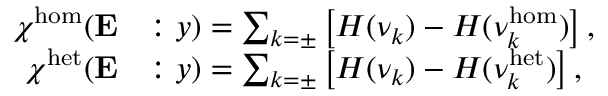Convert formula to latex. <formula><loc_0><loc_0><loc_500><loc_500>\begin{array} { r l } { \chi ^ { h o m } ( E } & { \colon y ) = \sum _ { k = \pm } \left [ H ( \nu _ { k } ) - H ( \nu _ { k } ^ { h o m } ) \right ] , } \\ { \chi ^ { h e t } ( E } & { \colon y ) = \sum _ { k = \pm } \left [ H ( \nu _ { k } ) - H ( \nu _ { k } ^ { h e t } ) \right ] , } \end{array}</formula> 